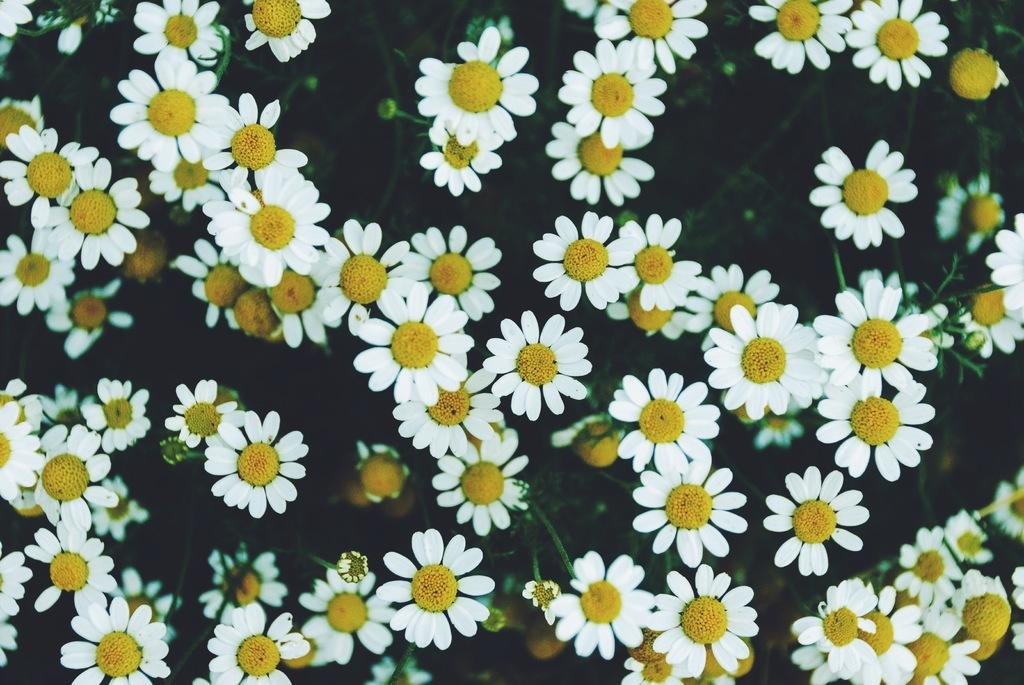What colors of flowers can be seen in the image? There are white flowers and yellow flowers in the image. What type of protest is taking place in the image? There is no protest present in the image; it features flowers of different colors. What time does the clock show in the image? There is no clock present in the image. Can you see a robin perched on any of the flowers in the image? There is no robin present in the image; it only features flowers. 